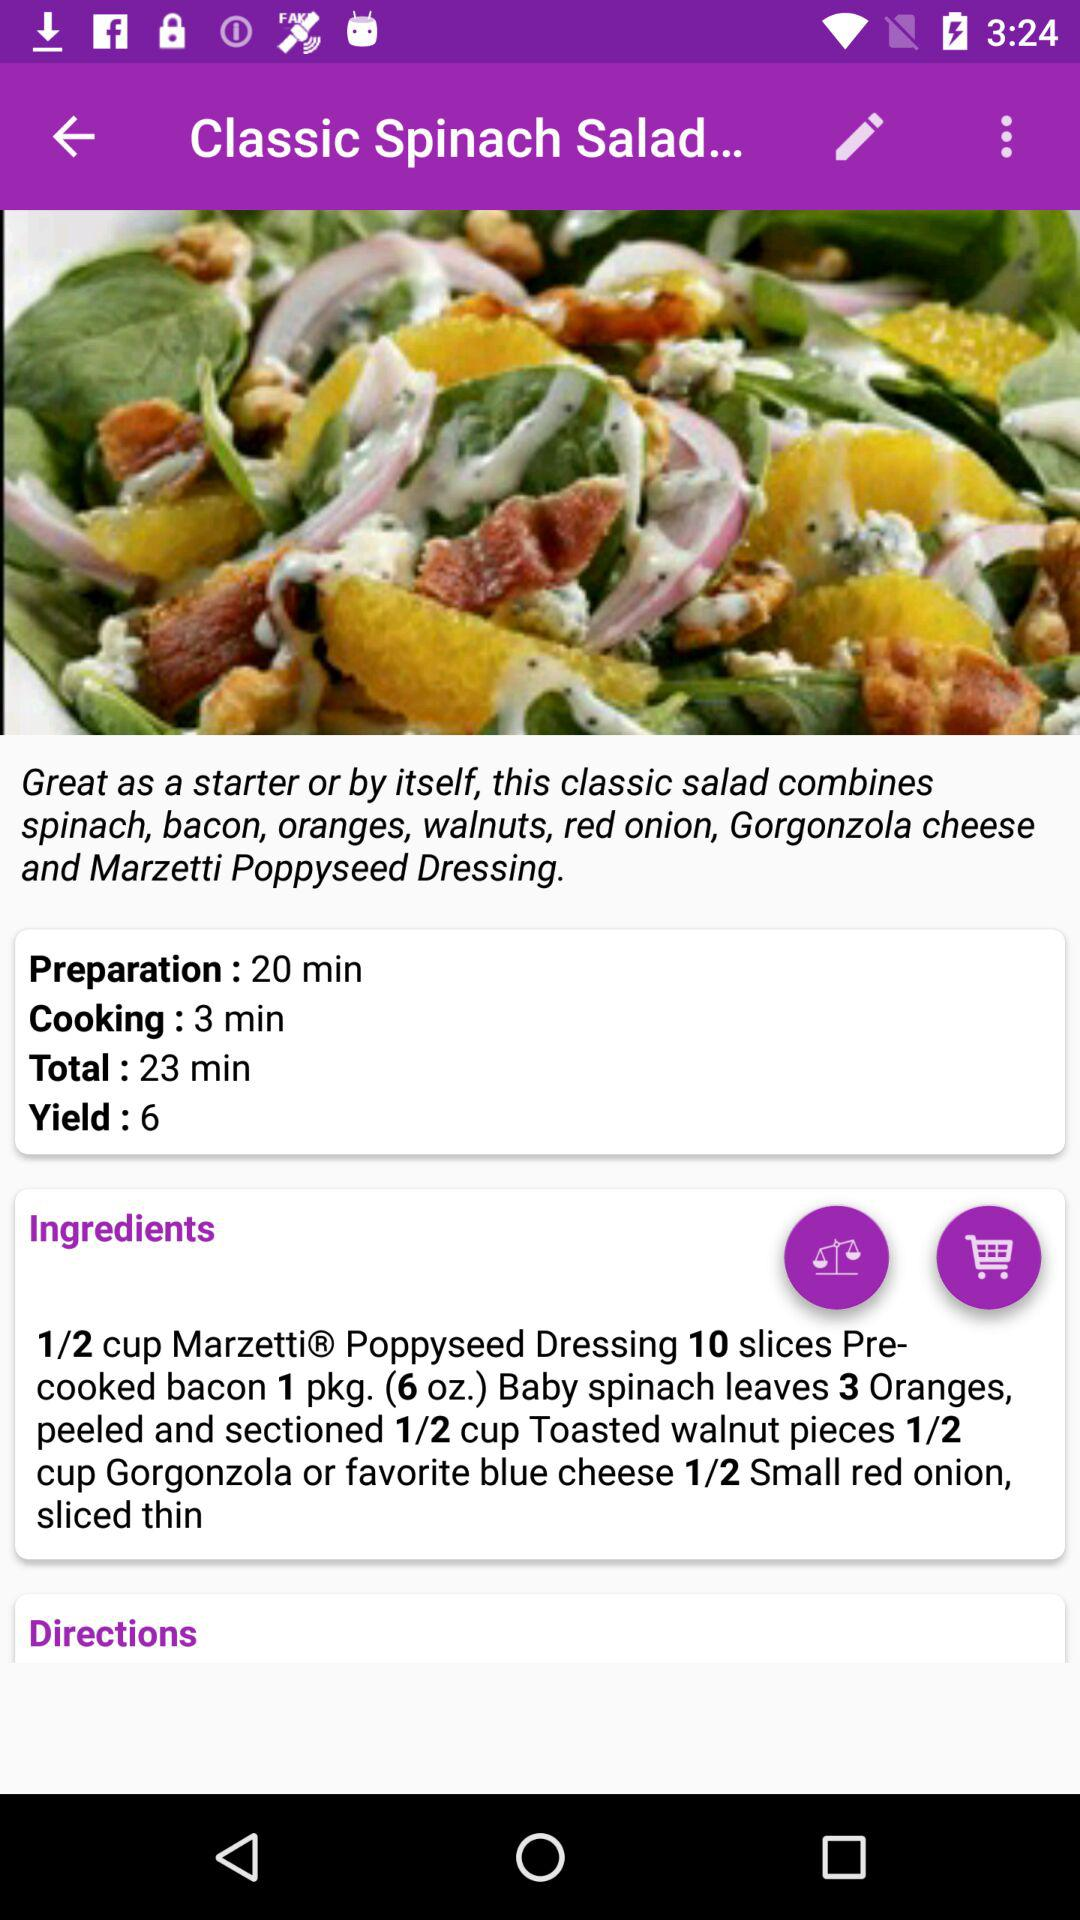What's the count of yield? The count of yield is 6. 